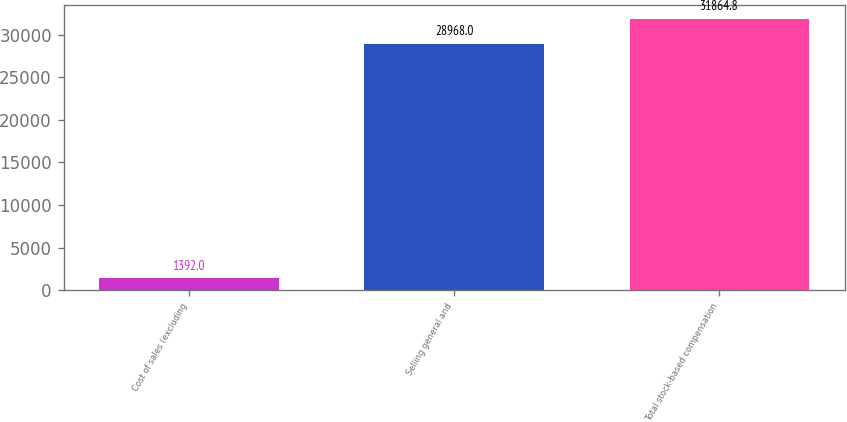Convert chart. <chart><loc_0><loc_0><loc_500><loc_500><bar_chart><fcel>Cost of sales (excluding<fcel>Selling general and<fcel>Total stock-based compensation<nl><fcel>1392<fcel>28968<fcel>31864.8<nl></chart> 